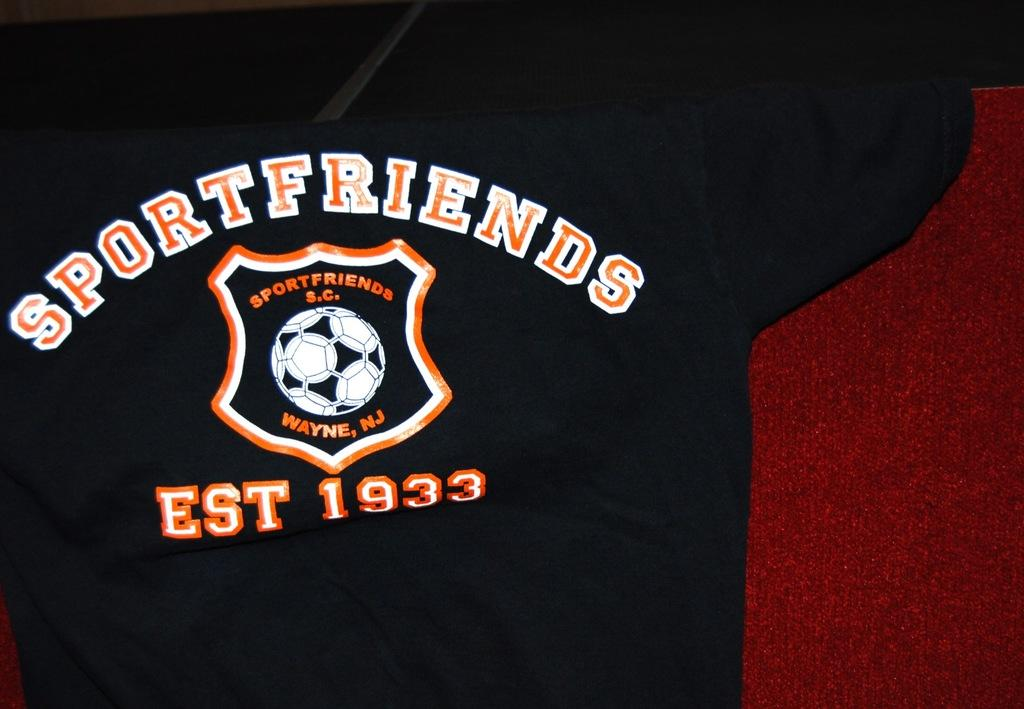What type of clothing item is in the image? There is a t-shirt in the image. What is written or printed on the t-shirt? The t-shirt has text and numbers on it. What else is featured on the t-shirt? The t-shirt has a logo on it. What can be seen in the background of the image? There are objects in the background of the image. What type of jelly is being used to create the logo on the t-shirt? There is no jelly present in the image, and the logo on the t-shirt is not made of jelly. 